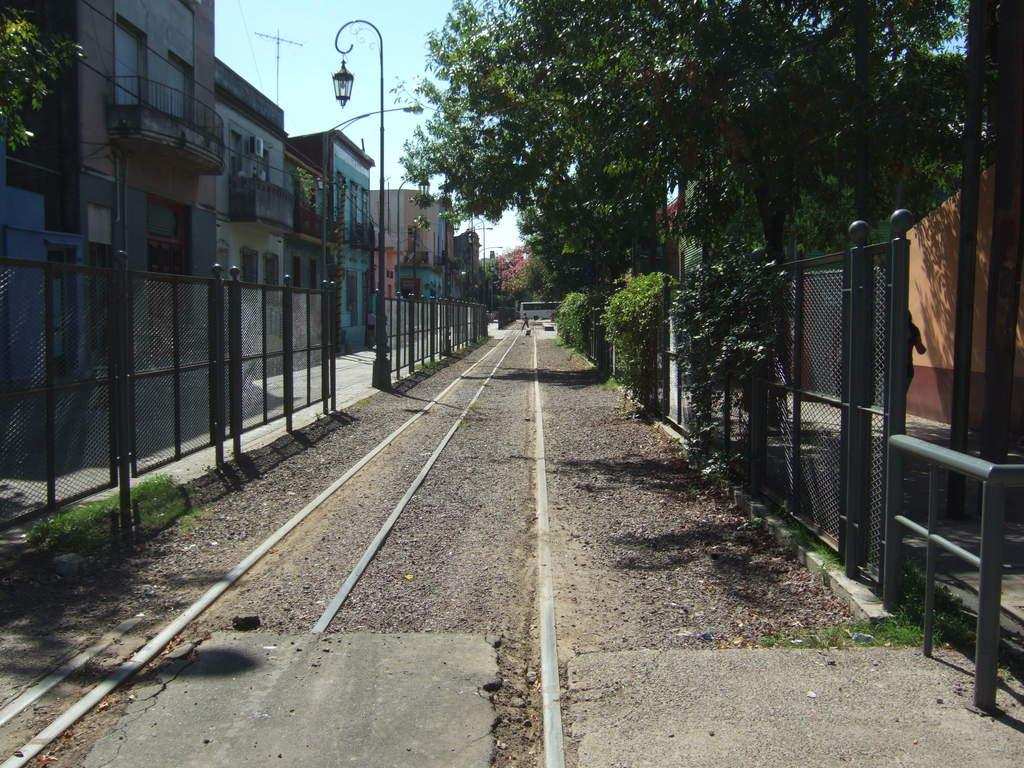What is located at the bottom of the image? There is a road at the bottom of the image. What features are present alongside the road? Railings, poles, trees, and buildings are visible on both sides of the road. What can be seen at the top of the image? The sky is visible at the top of the image. How many icicles are hanging from the railings in the image? There are no icicles present in the image. What type of control system is used to manage the traffic on the road in the image? There is no information about a control system in the image; it only shows the road, railings, poles, trees, buildings, and the sky. 